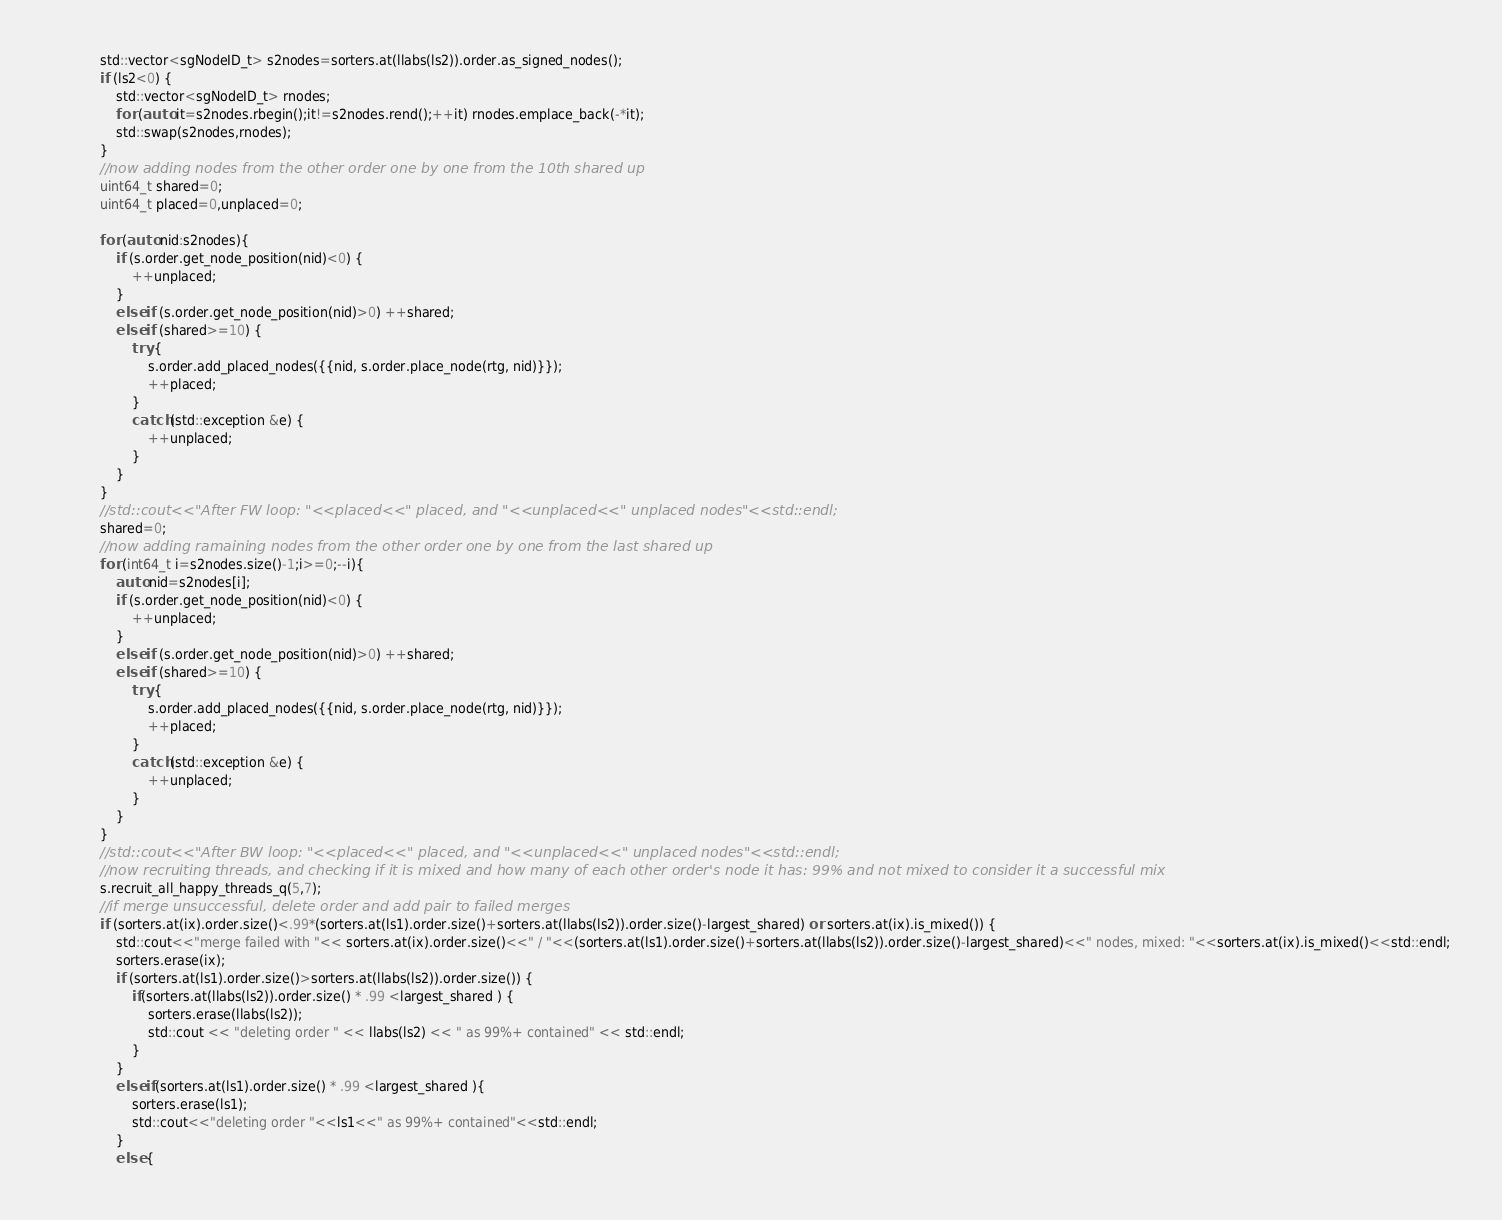Convert code to text. <code><loc_0><loc_0><loc_500><loc_500><_C++_>            std::vector<sgNodeID_t> s2nodes=sorters.at(llabs(ls2)).order.as_signed_nodes();
            if (ls2<0) {
                std::vector<sgNodeID_t> rnodes;
                for (auto it=s2nodes.rbegin();it!=s2nodes.rend();++it) rnodes.emplace_back(-*it);
                std::swap(s2nodes,rnodes);
            }
            //now adding nodes from the other order one by one from the 10th shared up
            uint64_t shared=0;
            uint64_t placed=0,unplaced=0;

            for (auto nid:s2nodes){
                if (s.order.get_node_position(nid)<0) {
                    ++unplaced;
                }
                else if (s.order.get_node_position(nid)>0) ++shared;
                else if (shared>=10) {
                    try {
                        s.order.add_placed_nodes({{nid, s.order.place_node(rtg, nid)}});
                        ++placed;
                    }
                    catch (std::exception &e) {
                        ++unplaced;
                    }
                }
            }
            //std::cout<<"After FW loop: "<<placed<<" placed, and "<<unplaced<<" unplaced nodes"<<std::endl;
            shared=0;
            //now adding ramaining nodes from the other order one by one from the last shared up
            for (int64_t i=s2nodes.size()-1;i>=0;--i){
                auto nid=s2nodes[i];
                if (s.order.get_node_position(nid)<0) {
                    ++unplaced;
                }
                else if (s.order.get_node_position(nid)>0) ++shared;
                else if (shared>=10) {
                    try {
                        s.order.add_placed_nodes({{nid, s.order.place_node(rtg, nid)}});
                        ++placed;
                    }
                    catch (std::exception &e) {
                        ++unplaced;
                    }
                }
            }
            //std::cout<<"After BW loop: "<<placed<<" placed, and "<<unplaced<<" unplaced nodes"<<std::endl;
            //now recruiting threads, and checking if it is mixed and how many of each other order's node it has: 99% and not mixed to consider it a successful mix
            s.recruit_all_happy_threads_q(5,7);
            //if merge unsuccessful, delete order and add pair to failed merges
            if (sorters.at(ix).order.size()<.99*(sorters.at(ls1).order.size()+sorters.at(llabs(ls2)).order.size()-largest_shared) or sorters.at(ix).is_mixed()) {
                std::cout<<"merge failed with "<< sorters.at(ix).order.size()<<" / "<<(sorters.at(ls1).order.size()+sorters.at(llabs(ls2)).order.size()-largest_shared)<<" nodes, mixed: "<<sorters.at(ix).is_mixed()<<std::endl;
                sorters.erase(ix);
                if (sorters.at(ls1).order.size()>sorters.at(llabs(ls2)).order.size()) {
                    if(sorters.at(llabs(ls2)).order.size() * .99 <largest_shared ) {
                        sorters.erase(llabs(ls2));
                        std::cout << "deleting order " << llabs(ls2) << " as 99%+ contained" << std::endl;
                    }
                }
                else if(sorters.at(ls1).order.size() * .99 <largest_shared ){
                    sorters.erase(ls1);
                    std::cout<<"deleting order "<<ls1<<" as 99%+ contained"<<std::endl;
                }
                else {</code> 